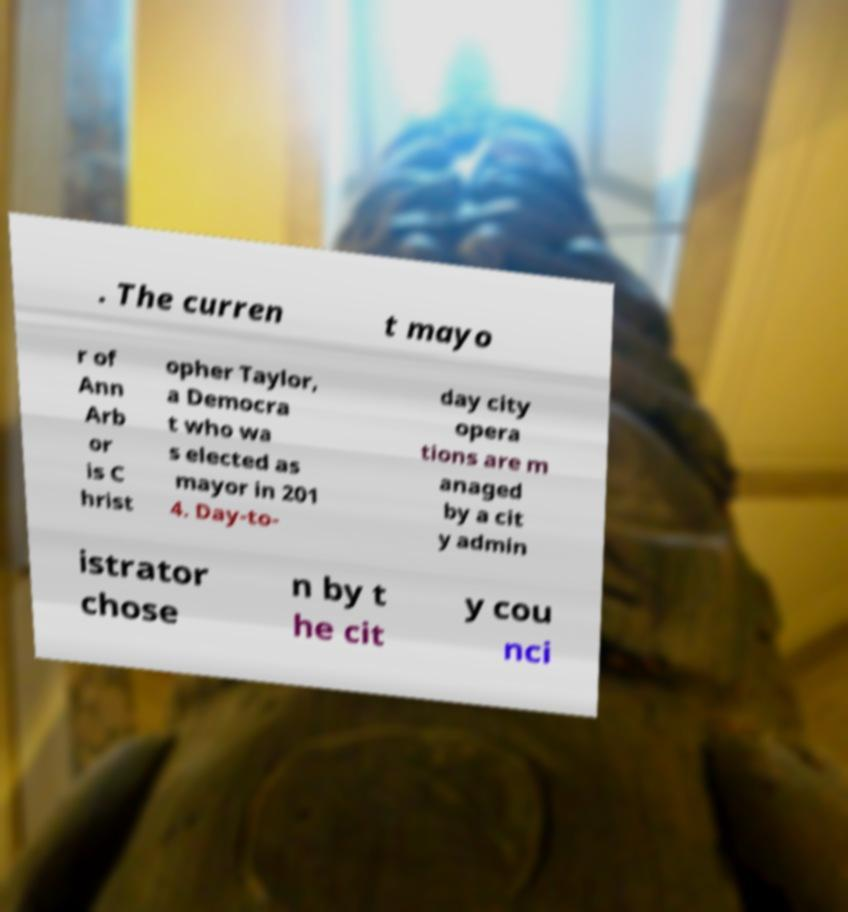Please read and relay the text visible in this image. What does it say? . The curren t mayo r of Ann Arb or is C hrist opher Taylor, a Democra t who wa s elected as mayor in 201 4. Day-to- day city opera tions are m anaged by a cit y admin istrator chose n by t he cit y cou nci 